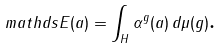Convert formula to latex. <formula><loc_0><loc_0><loc_500><loc_500>\ m a t h d s { E } ( a ) = \int _ { H } \alpha ^ { g } ( a ) \, d \mu ( g ) \text {.}</formula> 